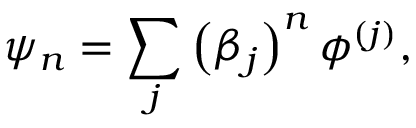Convert formula to latex. <formula><loc_0><loc_0><loc_500><loc_500>\psi _ { n } = \sum _ { j } \left ( \beta _ { j } \right ) ^ { n } \phi ^ { \left ( j \right ) } ,</formula> 